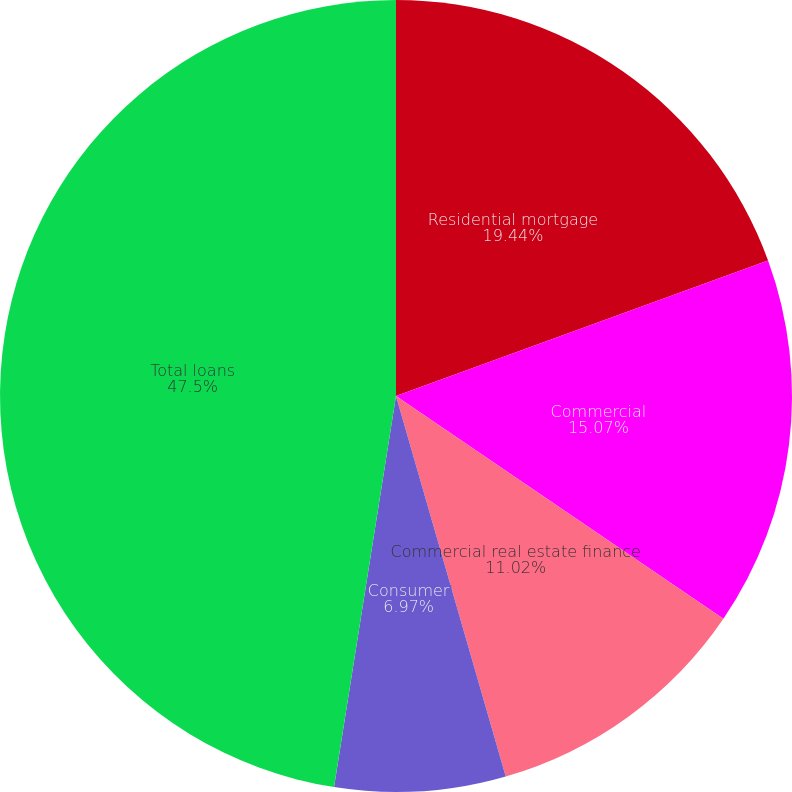Convert chart to OTSL. <chart><loc_0><loc_0><loc_500><loc_500><pie_chart><fcel>Residential mortgage<fcel>Commercial<fcel>Commercial real estate finance<fcel>Consumer<fcel>Total loans<nl><fcel>19.44%<fcel>15.07%<fcel>11.02%<fcel>6.97%<fcel>47.5%<nl></chart> 